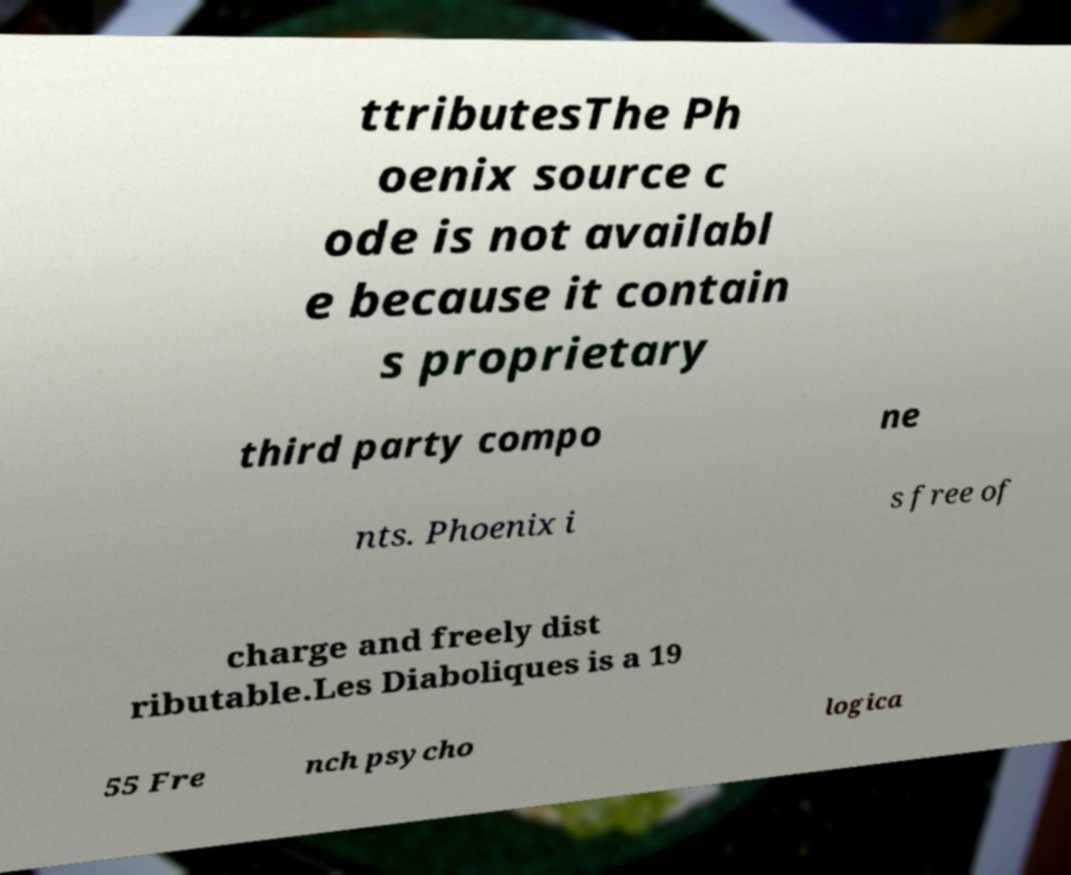What messages or text are displayed in this image? I need them in a readable, typed format. ttributesThe Ph oenix source c ode is not availabl e because it contain s proprietary third party compo ne nts. Phoenix i s free of charge and freely dist ributable.Les Diaboliques is a 19 55 Fre nch psycho logica 